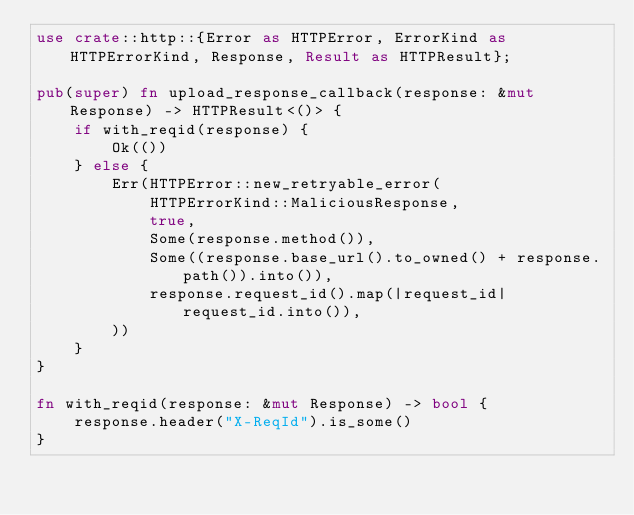<code> <loc_0><loc_0><loc_500><loc_500><_Rust_>use crate::http::{Error as HTTPError, ErrorKind as HTTPErrorKind, Response, Result as HTTPResult};

pub(super) fn upload_response_callback(response: &mut Response) -> HTTPResult<()> {
    if with_reqid(response) {
        Ok(())
    } else {
        Err(HTTPError::new_retryable_error(
            HTTPErrorKind::MaliciousResponse,
            true,
            Some(response.method()),
            Some((response.base_url().to_owned() + response.path()).into()),
            response.request_id().map(|request_id| request_id.into()),
        ))
    }
}

fn with_reqid(response: &mut Response) -> bool {
    response.header("X-ReqId").is_some()
}
</code> 